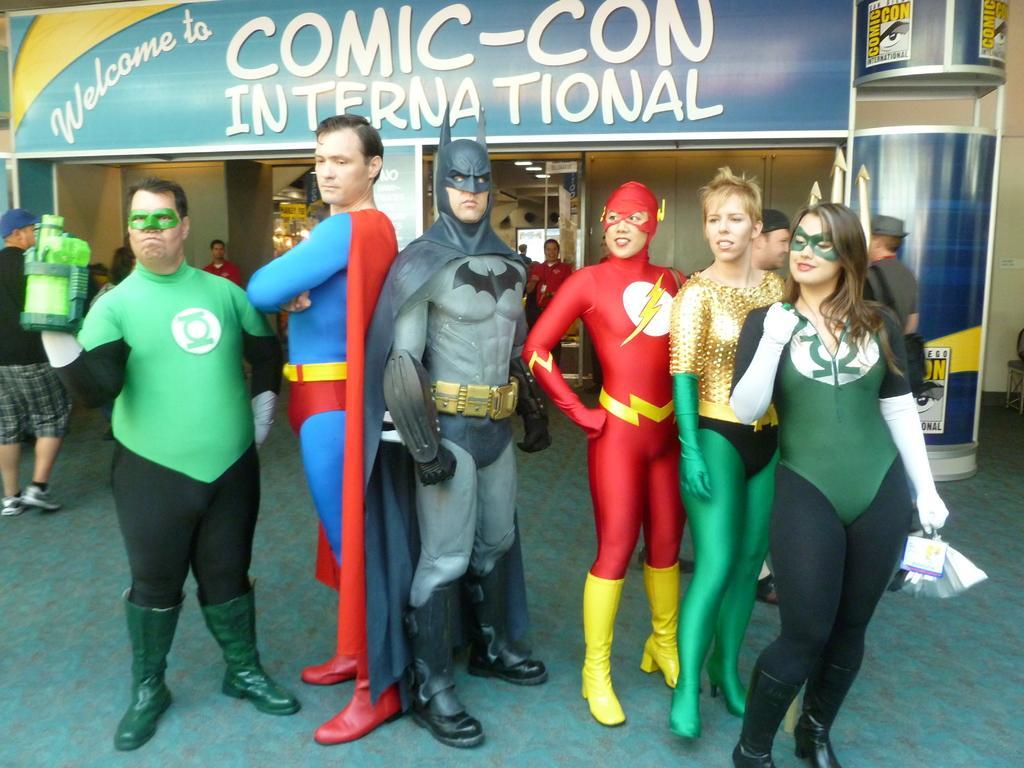Please provide a concise description of this image. This picture shows few people standing and they wore fancy dress and we see a man walking and we see a hoarding board with some text on it and few people standing on the back. 